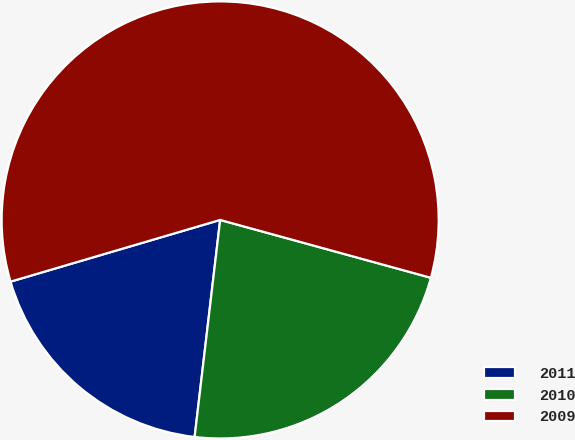Convert chart. <chart><loc_0><loc_0><loc_500><loc_500><pie_chart><fcel>2011<fcel>2010<fcel>2009<nl><fcel>18.58%<fcel>22.6%<fcel>58.82%<nl></chart> 